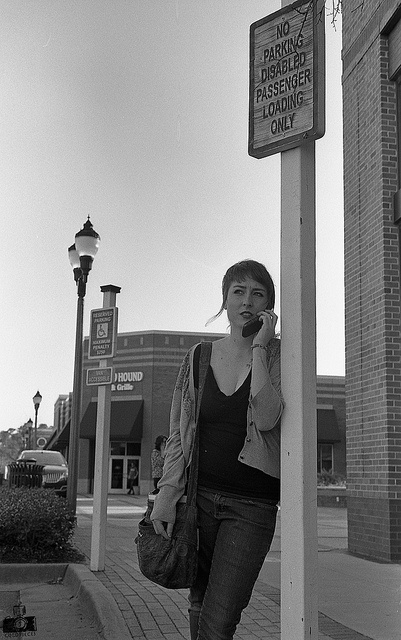Describe the objects in this image and their specific colors. I can see people in lightgray, black, and gray tones, handbag in lightgray, black, gray, and darkgray tones, car in lightgray, gray, darkgray, and black tones, people in black, gray, and lightgray tones, and cell phone in black, gray, and lightgray tones in this image. 